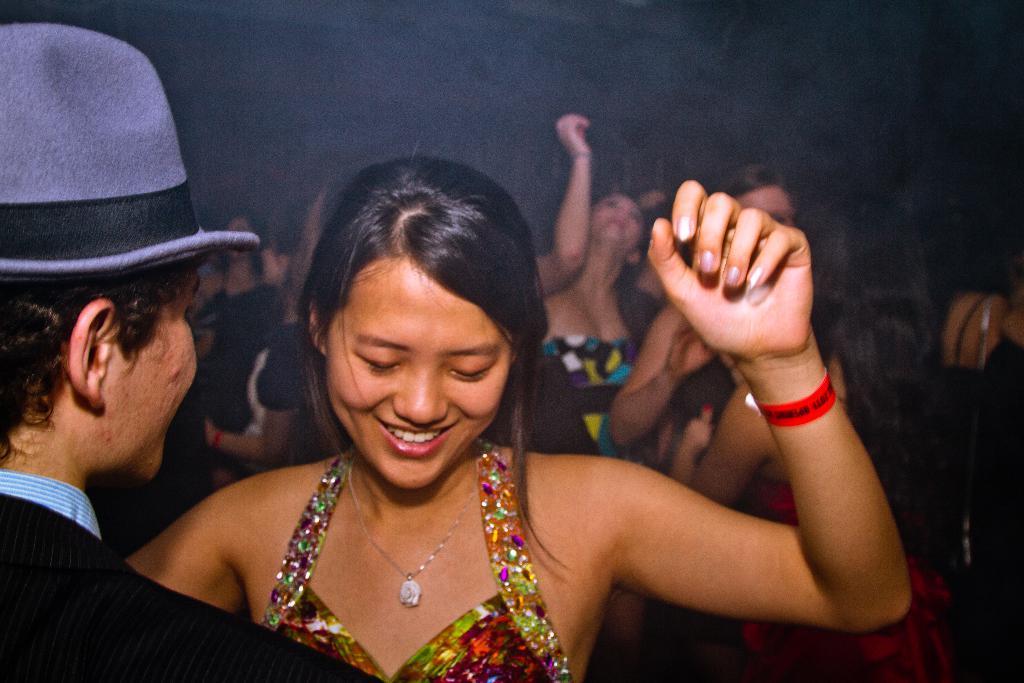Can you describe this image briefly? In the foreground of this image, on the left there is a man wearing hat and a woman in front of him. In the background, there are people in the dark. 